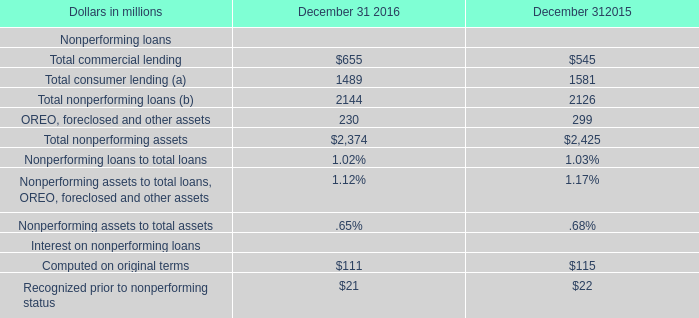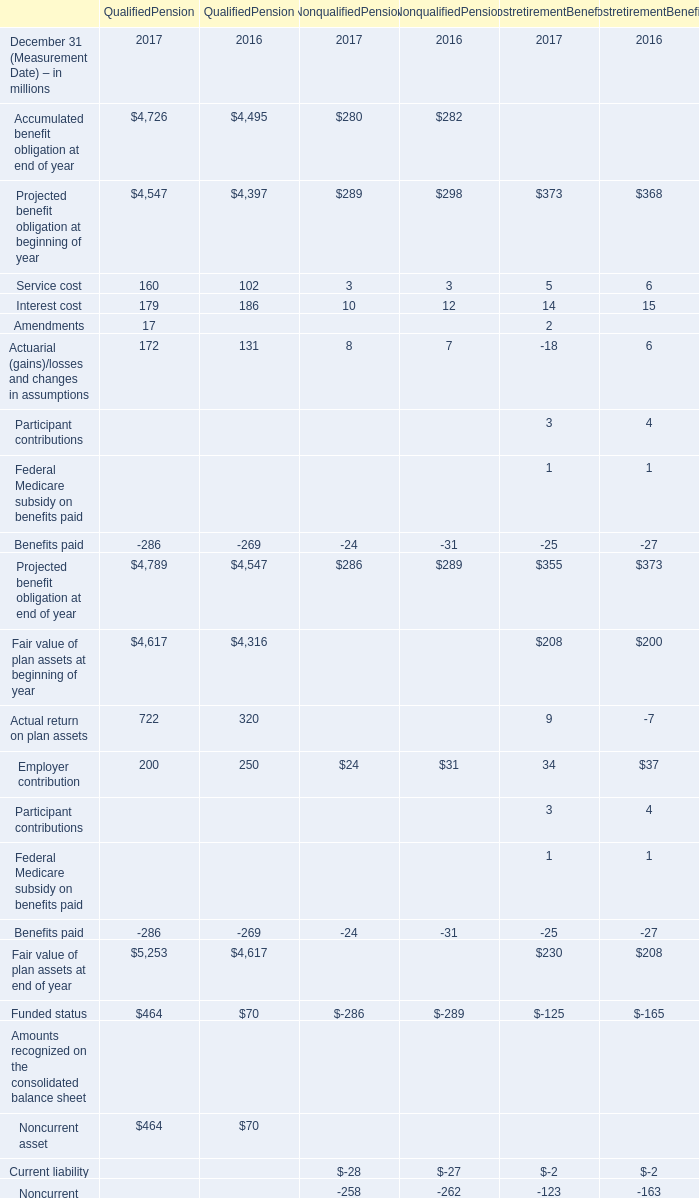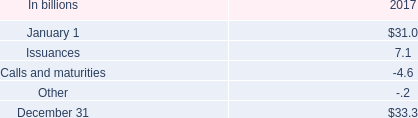2017 ending total liquid assets were what percent of total senior and subordinated debt? 
Computations: (90.6 / 33.3)
Answer: 2.72072. 